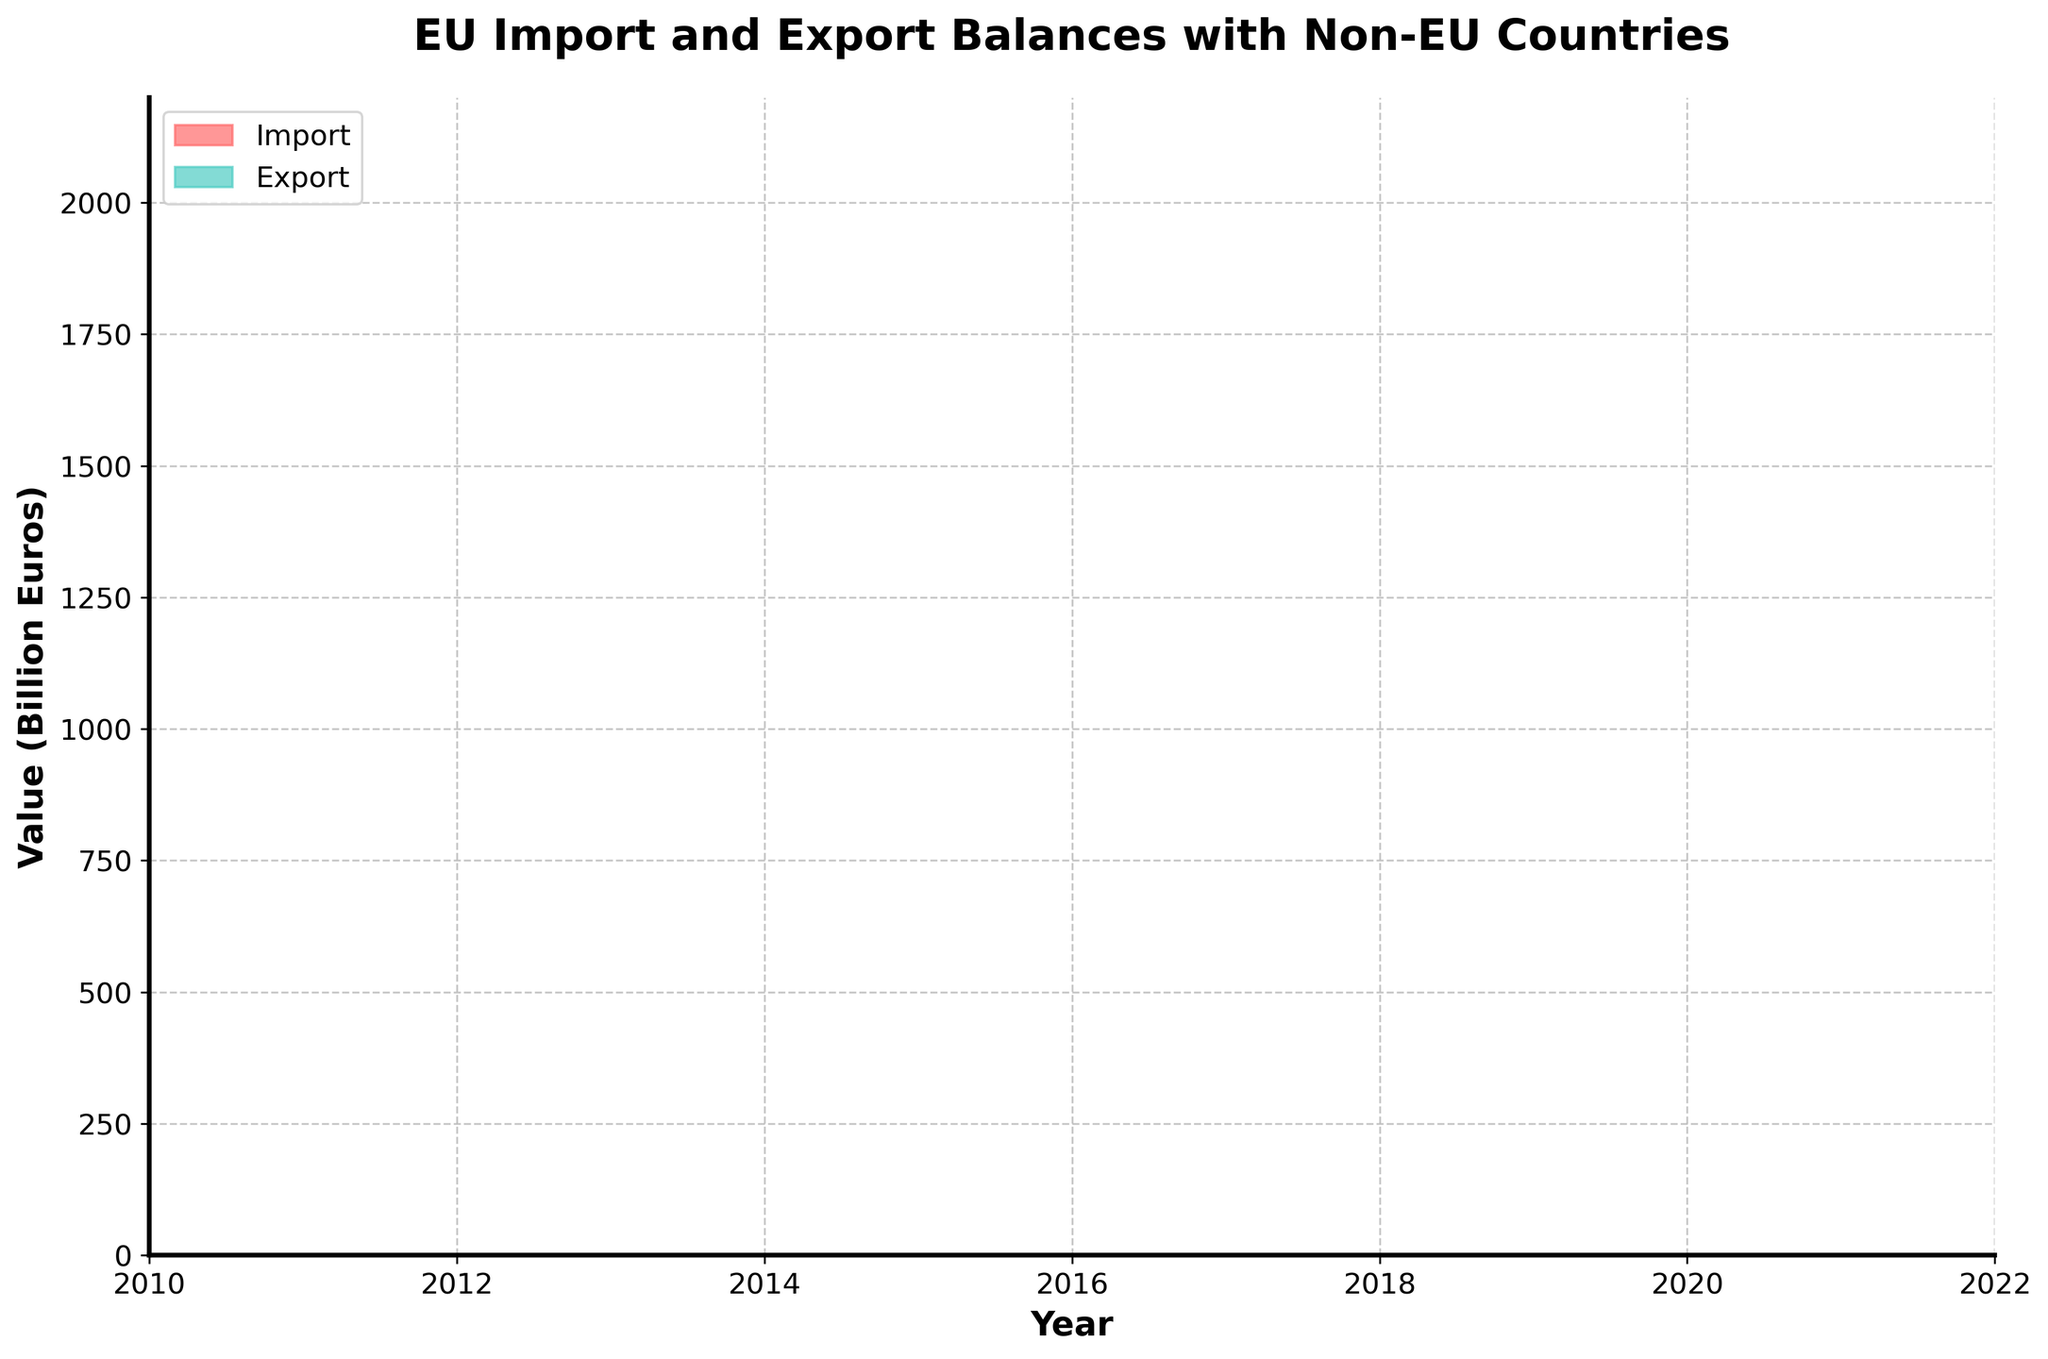What is the title of the chart? The title is located at the top center of the chart and describes the main topic. It is "EU Import and Export Balances with Non-EU Countries".
Answer: EU Import and Export Balances with Non-EU Countries What does the y-axis represent? The y-axis label can be found on the left side of the chart. It indicates the units or measurement of the data values. In this case, it is "Value (Billion Euros)".
Answer: Value (Billion Euros) Between which years does the chart show data? The x-axis represents time and the range of years is marked from one end to the other. The data spans from the year 2010 to 2022.
Answer: 2010 to 2022 Which year had the highest import value? By observing the top boundary of the red area, which represents imports, we identify the peak point. The year 2022 shows the highest value.
Answer: 2022 In which year did the exports value reach 1.45 billion euros? The green area represents exports. Checking along the x-axis until the top boundary of the green area intersects with the 1.45 billion euros mark on the y-axis, it falls on the year 2021.
Answer: 2021 What is the general trend of imports from 2010 to 2022? Looking at the shape of the red area from left to right, the general direction or slope gives the trend. Imports show an increasing trend over the years.
Answer: Increasing How much did the export values increase from 2010 to 2022? The export value in 2010 was the bottom edge of the green area at 0.95 billion euros and increased to 1.5 billion euros by 2022. The difference is calculated by subtracting the 2010 value from the 2022 value: 1.5 - 0.95.
Answer: 0.55 billion euros For which periods were imports consistently higher than exports? Observing the chart, the red area representing imports is above the green area representing exports for the entire time span from 2010 to 2022.
Answer: 2010 to 2022 How do the import values compare to export values in 2022? Find the respective areas for the year 2022 and compare their y-axis values. Imports are at 2 billion euros and exports are at 1.5 billion euros. Imports are higher than exports by the difference: 2 - 1.5.
Answer: 0.5 billion euros How much did the import values change between 2017 and 2018? Locate 2017 and 2018 on the x-axis and determine the corresponding import values from the y-axis. Imports were 1.6 billion euros in 2017 and 1.65 billion euros in 2018. The difference is calculated as 1.65 - 1.6.
Answer: 0.05 billion euros 